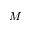Convert formula to latex. <formula><loc_0><loc_0><loc_500><loc_500>M</formula> 